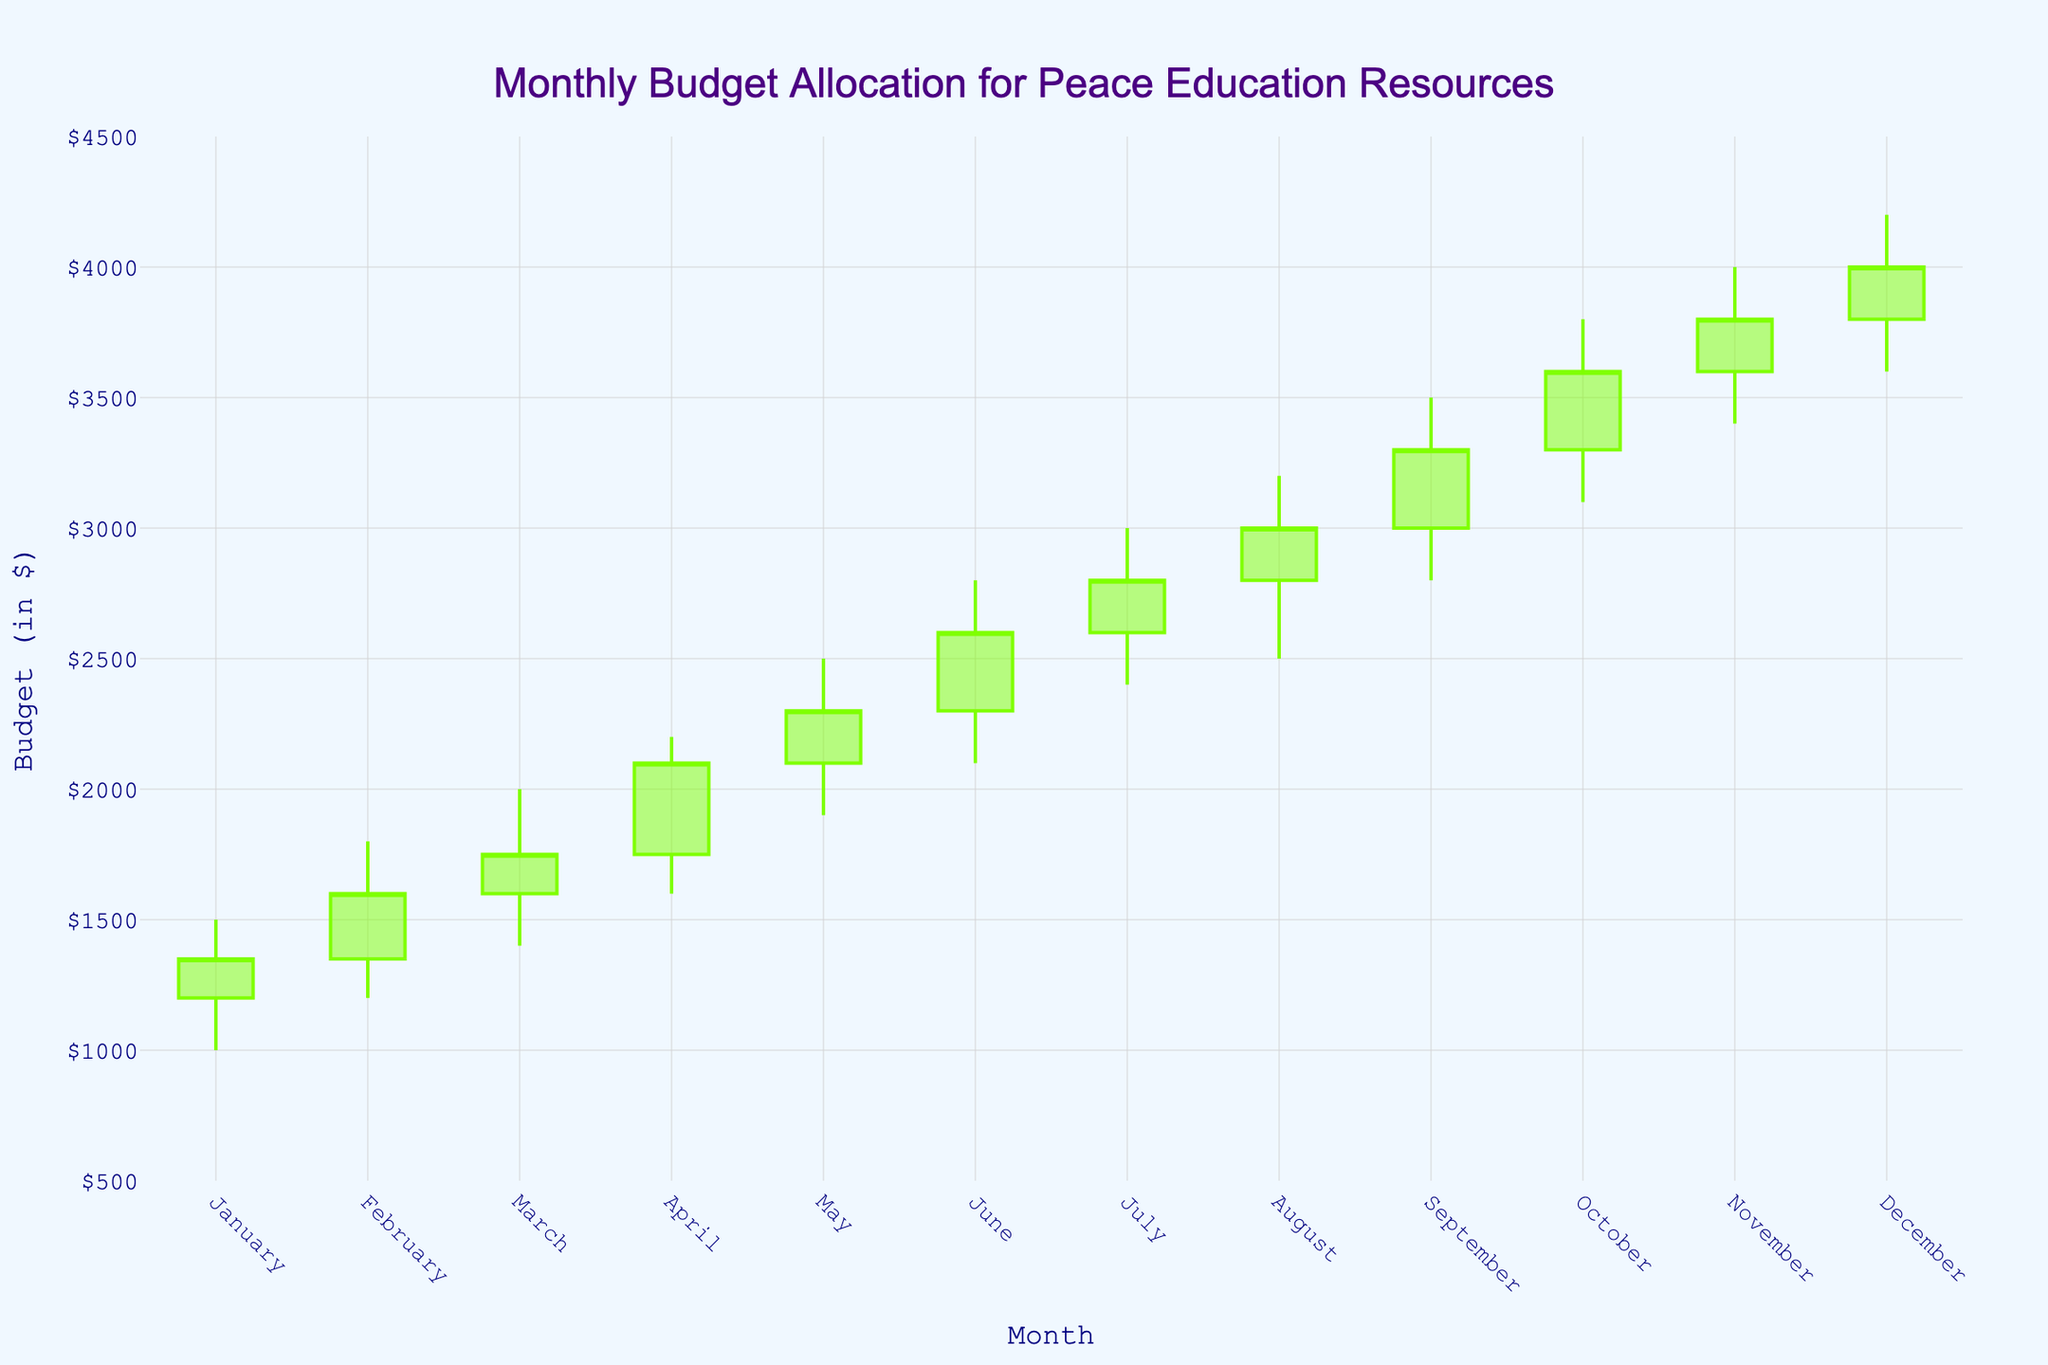What is the title of the figure? The figure's title is prominently displayed at the top center of the plot.
Answer: Monthly Budget Allocation for Peace Education Resources What does the x-axis represent? By looking at the x-axis, we can see the labels of the months of the year.
Answer: Month What is the minimum budget allocation recorded for any month? To find the minimum budget allocation, look for the smallest value in the 'Low' section of the candlestick plot.
Answer: $1000 Which month shows the highest spending in the budget? This involves looking at the 'high' value across all months and identifying the highest one, which corresponds to December for $4200.
Answer: December What's the average closing budget over the year? Add up all the closing values and then divide by the number of months (sum of closing values: 1350 + 1600 + 1750 + 2100 + 2300 + 2600 + 2800 + 3000 + 3300 + 3600 + 3800 + 4000) / 12 = 19100 / 12
Answer: $1591.67 How does the budget allocation in February compare to that in June? Compare the February candlestick's overall high ($1800) and low ($1200) values with June's high ($2800) and low ($2100).
Answer: February's range is lower than June's In which month did the budget allocation start at $2300 and what was the closing budget for that month? Look for the line where the 'Open' value is $2300, which corresponds to June, and note its 'Close' value ($2600).
Answer: June, $2600 Which month had the greatest difference between the high and low budget allocations? Calculate the differences for each month and find the greatest: January ($500), February ($600), March ($600), April ($600), May ($600), June ($700), July ($600), August ($700), September ($700), October ($700), November ($600), December ($800).
Answer: December What is the general trend in the budget allocations throughout the year? Visual inspection of the candlestick chart shows progressively increasing monthly high and low values, indicating a rising trend in budget allocations.
Answer: Increasing trend 